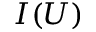Convert formula to latex. <formula><loc_0><loc_0><loc_500><loc_500>I ( U )</formula> 